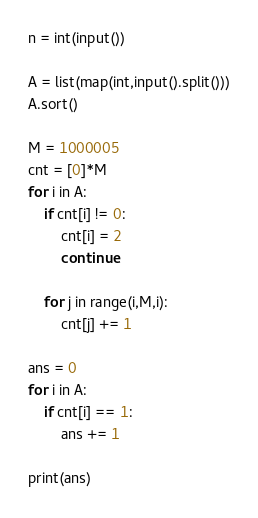<code> <loc_0><loc_0><loc_500><loc_500><_Python_>n = int(input())

A = list(map(int,input().split()))
A.sort()

M = 1000005
cnt = [0]*M
for i in A:
    if cnt[i] != 0:
        cnt[i] = 2
        continue
    
    for j in range(i,M,i):
        cnt[j] += 1

ans = 0
for i in A:
    if cnt[i] == 1:
        ans += 1
        
print(ans)</code> 